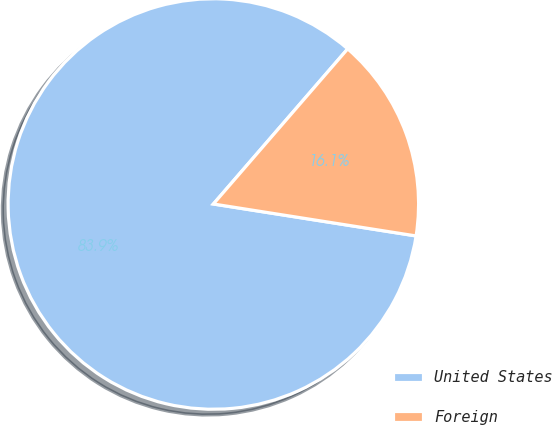Convert chart to OTSL. <chart><loc_0><loc_0><loc_500><loc_500><pie_chart><fcel>United States<fcel>Foreign<nl><fcel>83.87%<fcel>16.13%<nl></chart> 